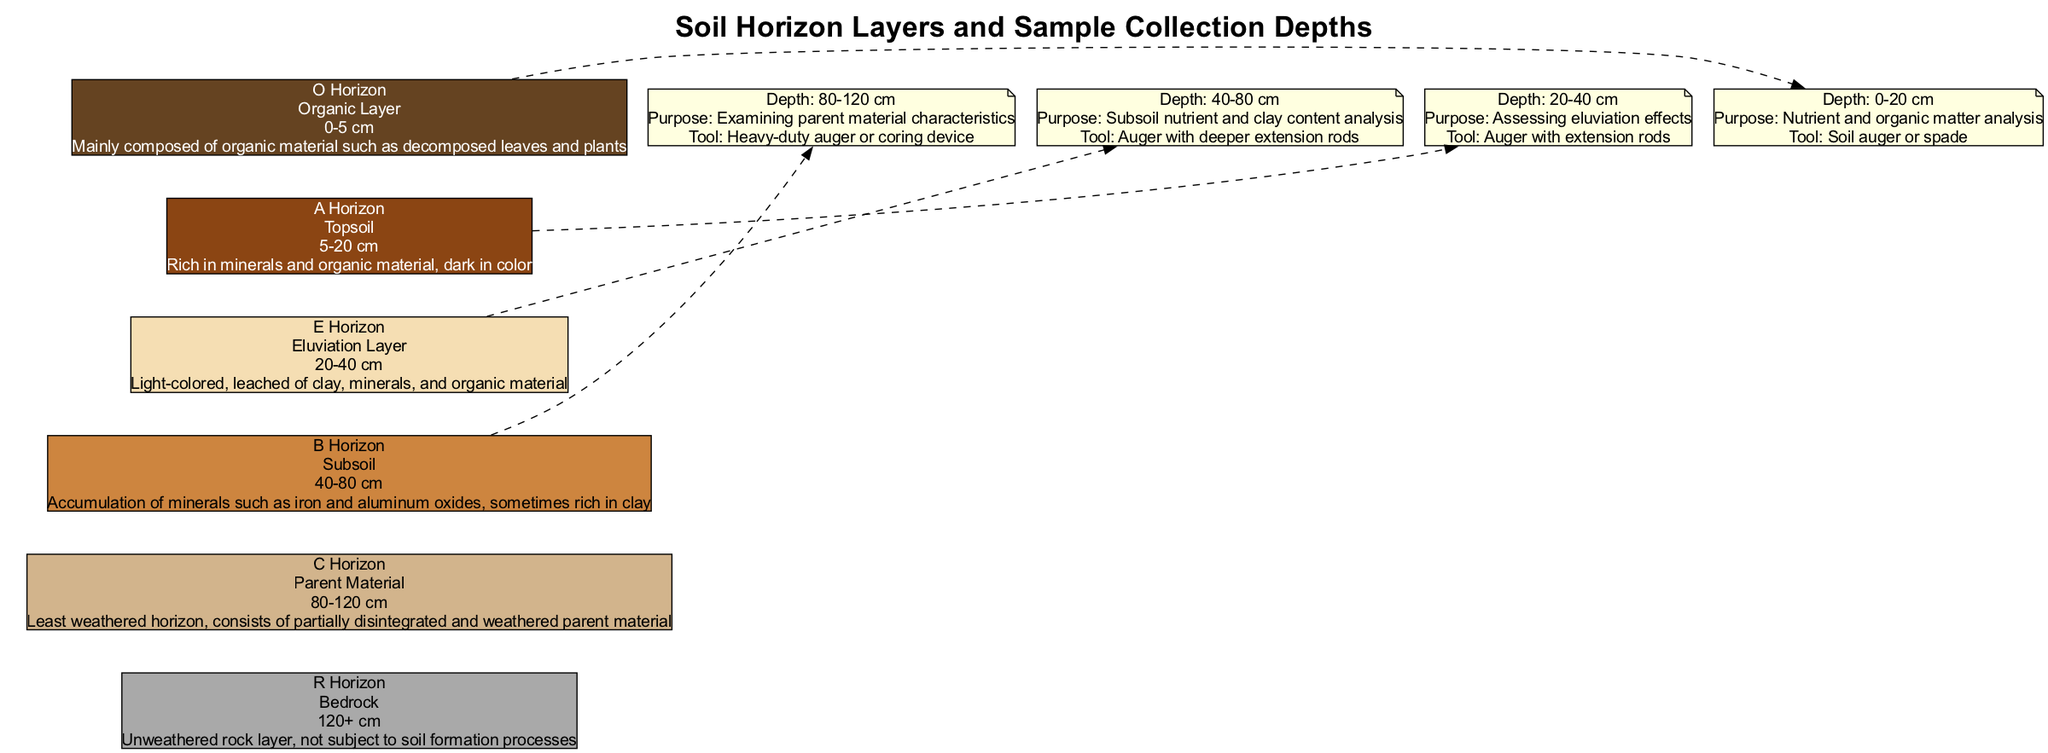What is the depth range of the O Horizon? Referring to the diagram's data on the O Horizon, it is explicitly stated that the depth range is from 0 to 5 cm.
Answer: 0-5 cm What is the main characteristic of the A Horizon? The A Horizon is described to be rich in minerals and organic material and is dark in color. This is a key characteristic highlighted in the layer's description.
Answer: Rich in minerals and organic material, dark in color How many soil horizons are represented in the diagram? By counting the listed soil horizons in the provided data, there are six distinct horizons from O to R.
Answer: 6 What tool is recommended for sampling in the depth range of 20-40 cm? The diagram suggests using an auger with extension rods for sampling within the specified depth range, indicating the appropriate tool for this depth.
Answer: Auger with extension rods What purpose does sampling from 40-80 cm serve? The sampling from this depth is intended for analyzing subsoil nutrient and clay content, as stated in the notes accompanying the sampling depth.
Answer: Subsoil nutrient and clay content analysis Which horizon is primarily composed of organic material? The diagram specifies that the O Horizon is mainly composed of organic material such as decomposed leaves and plants, making it the composition-focused answer.
Answer: O Horizon Which two horizons have a depth range of 20-40 cm? The E Horizon is specifically at this depth range, and the sampling purpose notes also indicate this depth for assessing eluviation effects.
Answer: E Horizon What color code represents the B Horizon? The color coding provided in the visual guide lists the B Horizon as '#CD853F', identifying its representation in the diagram.
Answer: #CD853F What is the purpose of sampling from 80-120 cm? According to the data, this sampling is designed to examine the characteristics of the parent material located at this depth range.
Answer: Examining parent material characteristics 